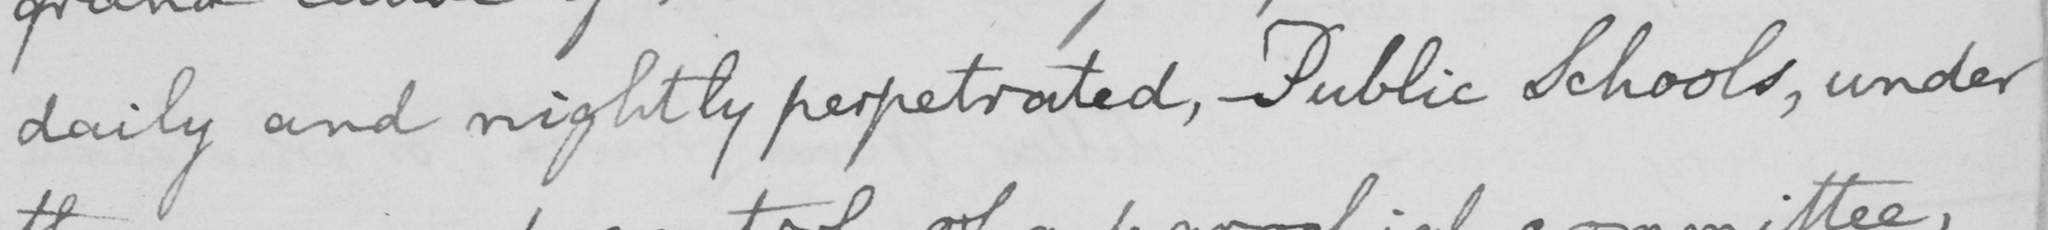Can you tell me what this handwritten text says? daily and nightly perpetrated , Public Schools , under 